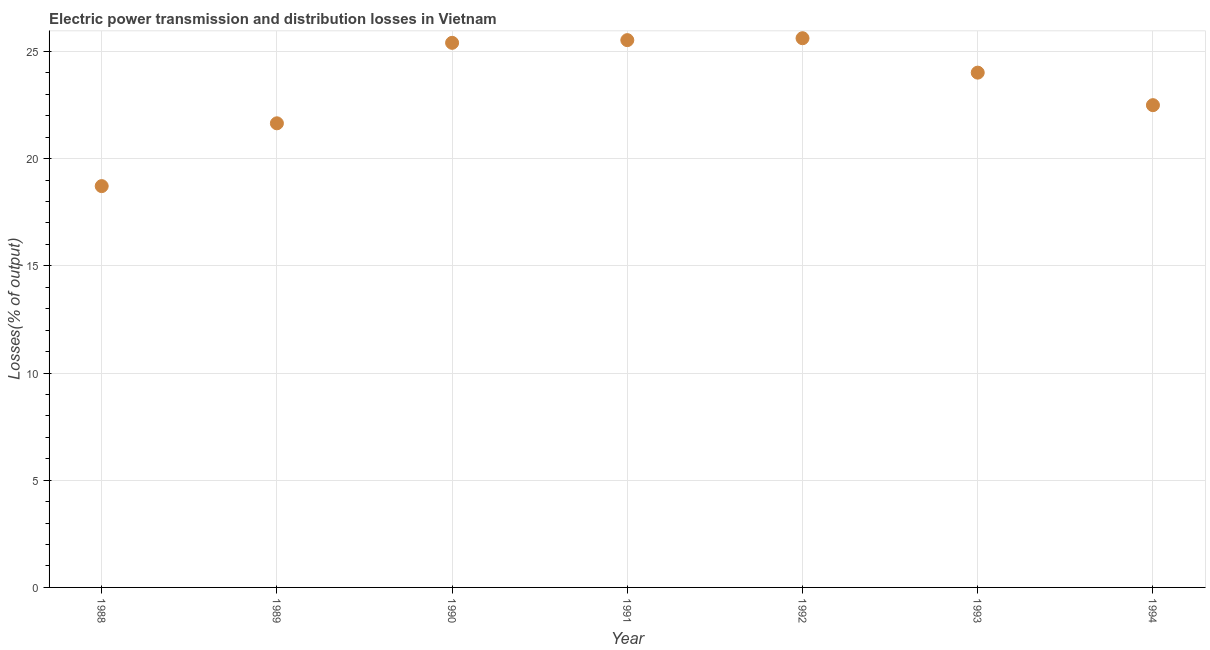What is the electric power transmission and distribution losses in 1992?
Offer a very short reply. 25.62. Across all years, what is the maximum electric power transmission and distribution losses?
Ensure brevity in your answer.  25.62. Across all years, what is the minimum electric power transmission and distribution losses?
Ensure brevity in your answer.  18.72. In which year was the electric power transmission and distribution losses maximum?
Provide a short and direct response. 1992. In which year was the electric power transmission and distribution losses minimum?
Provide a short and direct response. 1988. What is the sum of the electric power transmission and distribution losses?
Provide a short and direct response. 163.41. What is the difference between the electric power transmission and distribution losses in 1989 and 1993?
Keep it short and to the point. -2.36. What is the average electric power transmission and distribution losses per year?
Provide a short and direct response. 23.34. What is the median electric power transmission and distribution losses?
Your answer should be compact. 24.01. Do a majority of the years between 1993 and 1988 (inclusive) have electric power transmission and distribution losses greater than 1 %?
Offer a terse response. Yes. What is the ratio of the electric power transmission and distribution losses in 1988 to that in 1993?
Your response must be concise. 0.78. Is the electric power transmission and distribution losses in 1990 less than that in 1991?
Give a very brief answer. Yes. What is the difference between the highest and the second highest electric power transmission and distribution losses?
Offer a very short reply. 0.09. Is the sum of the electric power transmission and distribution losses in 1988 and 1993 greater than the maximum electric power transmission and distribution losses across all years?
Offer a very short reply. Yes. What is the difference between the highest and the lowest electric power transmission and distribution losses?
Your response must be concise. 6.9. In how many years, is the electric power transmission and distribution losses greater than the average electric power transmission and distribution losses taken over all years?
Offer a terse response. 4. Does the electric power transmission and distribution losses monotonically increase over the years?
Provide a succinct answer. No. Does the graph contain any zero values?
Give a very brief answer. No. What is the title of the graph?
Provide a succinct answer. Electric power transmission and distribution losses in Vietnam. What is the label or title of the Y-axis?
Make the answer very short. Losses(% of output). What is the Losses(% of output) in 1988?
Offer a very short reply. 18.72. What is the Losses(% of output) in 1989?
Ensure brevity in your answer.  21.65. What is the Losses(% of output) in 1990?
Provide a short and direct response. 25.4. What is the Losses(% of output) in 1991?
Ensure brevity in your answer.  25.53. What is the Losses(% of output) in 1992?
Your answer should be very brief. 25.62. What is the Losses(% of output) in 1993?
Your answer should be very brief. 24.01. What is the Losses(% of output) in 1994?
Your response must be concise. 22.49. What is the difference between the Losses(% of output) in 1988 and 1989?
Your answer should be very brief. -2.93. What is the difference between the Losses(% of output) in 1988 and 1990?
Your answer should be compact. -6.68. What is the difference between the Losses(% of output) in 1988 and 1991?
Your response must be concise. -6.81. What is the difference between the Losses(% of output) in 1988 and 1992?
Provide a succinct answer. -6.9. What is the difference between the Losses(% of output) in 1988 and 1993?
Provide a succinct answer. -5.29. What is the difference between the Losses(% of output) in 1988 and 1994?
Make the answer very short. -3.78. What is the difference between the Losses(% of output) in 1989 and 1990?
Offer a terse response. -3.75. What is the difference between the Losses(% of output) in 1989 and 1991?
Provide a succinct answer. -3.88. What is the difference between the Losses(% of output) in 1989 and 1992?
Keep it short and to the point. -3.97. What is the difference between the Losses(% of output) in 1989 and 1993?
Your answer should be very brief. -2.36. What is the difference between the Losses(% of output) in 1989 and 1994?
Ensure brevity in your answer.  -0.85. What is the difference between the Losses(% of output) in 1990 and 1991?
Give a very brief answer. -0.13. What is the difference between the Losses(% of output) in 1990 and 1992?
Your response must be concise. -0.22. What is the difference between the Losses(% of output) in 1990 and 1993?
Your answer should be compact. 1.39. What is the difference between the Losses(% of output) in 1990 and 1994?
Your answer should be very brief. 2.91. What is the difference between the Losses(% of output) in 1991 and 1992?
Provide a short and direct response. -0.09. What is the difference between the Losses(% of output) in 1991 and 1993?
Give a very brief answer. 1.52. What is the difference between the Losses(% of output) in 1991 and 1994?
Provide a succinct answer. 3.03. What is the difference between the Losses(% of output) in 1992 and 1993?
Your response must be concise. 1.61. What is the difference between the Losses(% of output) in 1992 and 1994?
Your answer should be very brief. 3.12. What is the difference between the Losses(% of output) in 1993 and 1994?
Your answer should be compact. 1.52. What is the ratio of the Losses(% of output) in 1988 to that in 1989?
Offer a very short reply. 0.86. What is the ratio of the Losses(% of output) in 1988 to that in 1990?
Make the answer very short. 0.74. What is the ratio of the Losses(% of output) in 1988 to that in 1991?
Give a very brief answer. 0.73. What is the ratio of the Losses(% of output) in 1988 to that in 1992?
Your answer should be compact. 0.73. What is the ratio of the Losses(% of output) in 1988 to that in 1993?
Provide a short and direct response. 0.78. What is the ratio of the Losses(% of output) in 1988 to that in 1994?
Your answer should be compact. 0.83. What is the ratio of the Losses(% of output) in 1989 to that in 1990?
Offer a very short reply. 0.85. What is the ratio of the Losses(% of output) in 1989 to that in 1991?
Provide a succinct answer. 0.85. What is the ratio of the Losses(% of output) in 1989 to that in 1992?
Provide a succinct answer. 0.84. What is the ratio of the Losses(% of output) in 1989 to that in 1993?
Your answer should be very brief. 0.9. What is the ratio of the Losses(% of output) in 1989 to that in 1994?
Ensure brevity in your answer.  0.96. What is the ratio of the Losses(% of output) in 1990 to that in 1991?
Ensure brevity in your answer.  0.99. What is the ratio of the Losses(% of output) in 1990 to that in 1993?
Your answer should be very brief. 1.06. What is the ratio of the Losses(% of output) in 1990 to that in 1994?
Keep it short and to the point. 1.13. What is the ratio of the Losses(% of output) in 1991 to that in 1992?
Offer a terse response. 1. What is the ratio of the Losses(% of output) in 1991 to that in 1993?
Keep it short and to the point. 1.06. What is the ratio of the Losses(% of output) in 1991 to that in 1994?
Provide a succinct answer. 1.14. What is the ratio of the Losses(% of output) in 1992 to that in 1993?
Your answer should be compact. 1.07. What is the ratio of the Losses(% of output) in 1992 to that in 1994?
Your answer should be very brief. 1.14. What is the ratio of the Losses(% of output) in 1993 to that in 1994?
Your response must be concise. 1.07. 